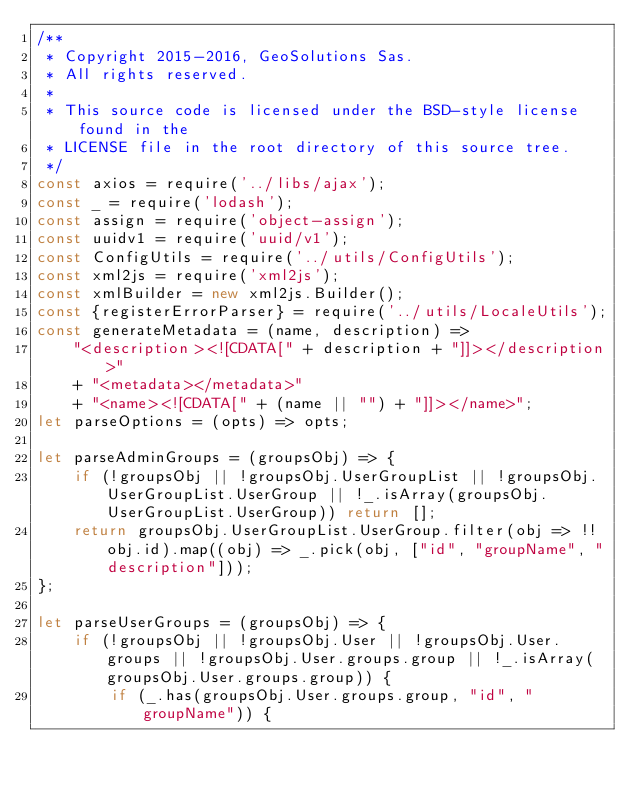Convert code to text. <code><loc_0><loc_0><loc_500><loc_500><_JavaScript_>/**
 * Copyright 2015-2016, GeoSolutions Sas.
 * All rights reserved.
 *
 * This source code is licensed under the BSD-style license found in the
 * LICENSE file in the root directory of this source tree.
 */
const axios = require('../libs/ajax');
const _ = require('lodash');
const assign = require('object-assign');
const uuidv1 = require('uuid/v1');
const ConfigUtils = require('../utils/ConfigUtils');
const xml2js = require('xml2js');
const xmlBuilder = new xml2js.Builder();
const {registerErrorParser} = require('../utils/LocaleUtils');
const generateMetadata = (name, description) =>
    "<description><![CDATA[" + description + "]]></description>"
    + "<metadata></metadata>"
    + "<name><![CDATA[" + (name || "") + "]]></name>";
let parseOptions = (opts) => opts;

let parseAdminGroups = (groupsObj) => {
    if (!groupsObj || !groupsObj.UserGroupList || !groupsObj.UserGroupList.UserGroup || !_.isArray(groupsObj.UserGroupList.UserGroup)) return [];
    return groupsObj.UserGroupList.UserGroup.filter(obj => !!obj.id).map((obj) => _.pick(obj, ["id", "groupName", "description"]));
};

let parseUserGroups = (groupsObj) => {
    if (!groupsObj || !groupsObj.User || !groupsObj.User.groups || !groupsObj.User.groups.group || !_.isArray(groupsObj.User.groups.group)) {
        if (_.has(groupsObj.User.groups.group, "id", "groupName")) {</code> 